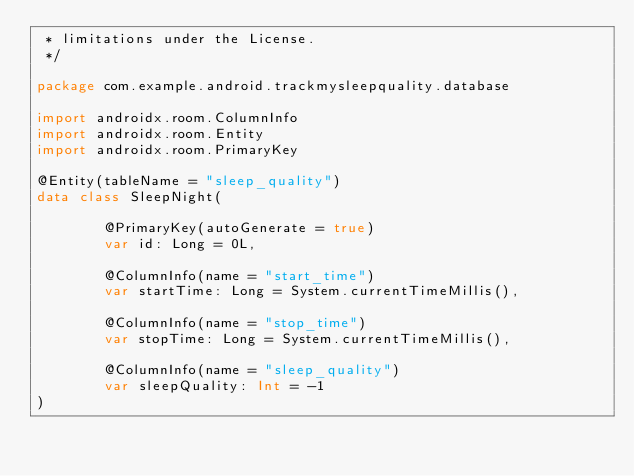Convert code to text. <code><loc_0><loc_0><loc_500><loc_500><_Kotlin_> * limitations under the License.
 */

package com.example.android.trackmysleepquality.database

import androidx.room.ColumnInfo
import androidx.room.Entity
import androidx.room.PrimaryKey

@Entity(tableName = "sleep_quality")
data class SleepNight(

        @PrimaryKey(autoGenerate = true)
        var id: Long = 0L,

        @ColumnInfo(name = "start_time")
        var startTime: Long = System.currentTimeMillis(),

        @ColumnInfo(name = "stop_time")
        var stopTime: Long = System.currentTimeMillis(),

        @ColumnInfo(name = "sleep_quality")
        var sleepQuality: Int = -1
)

</code> 